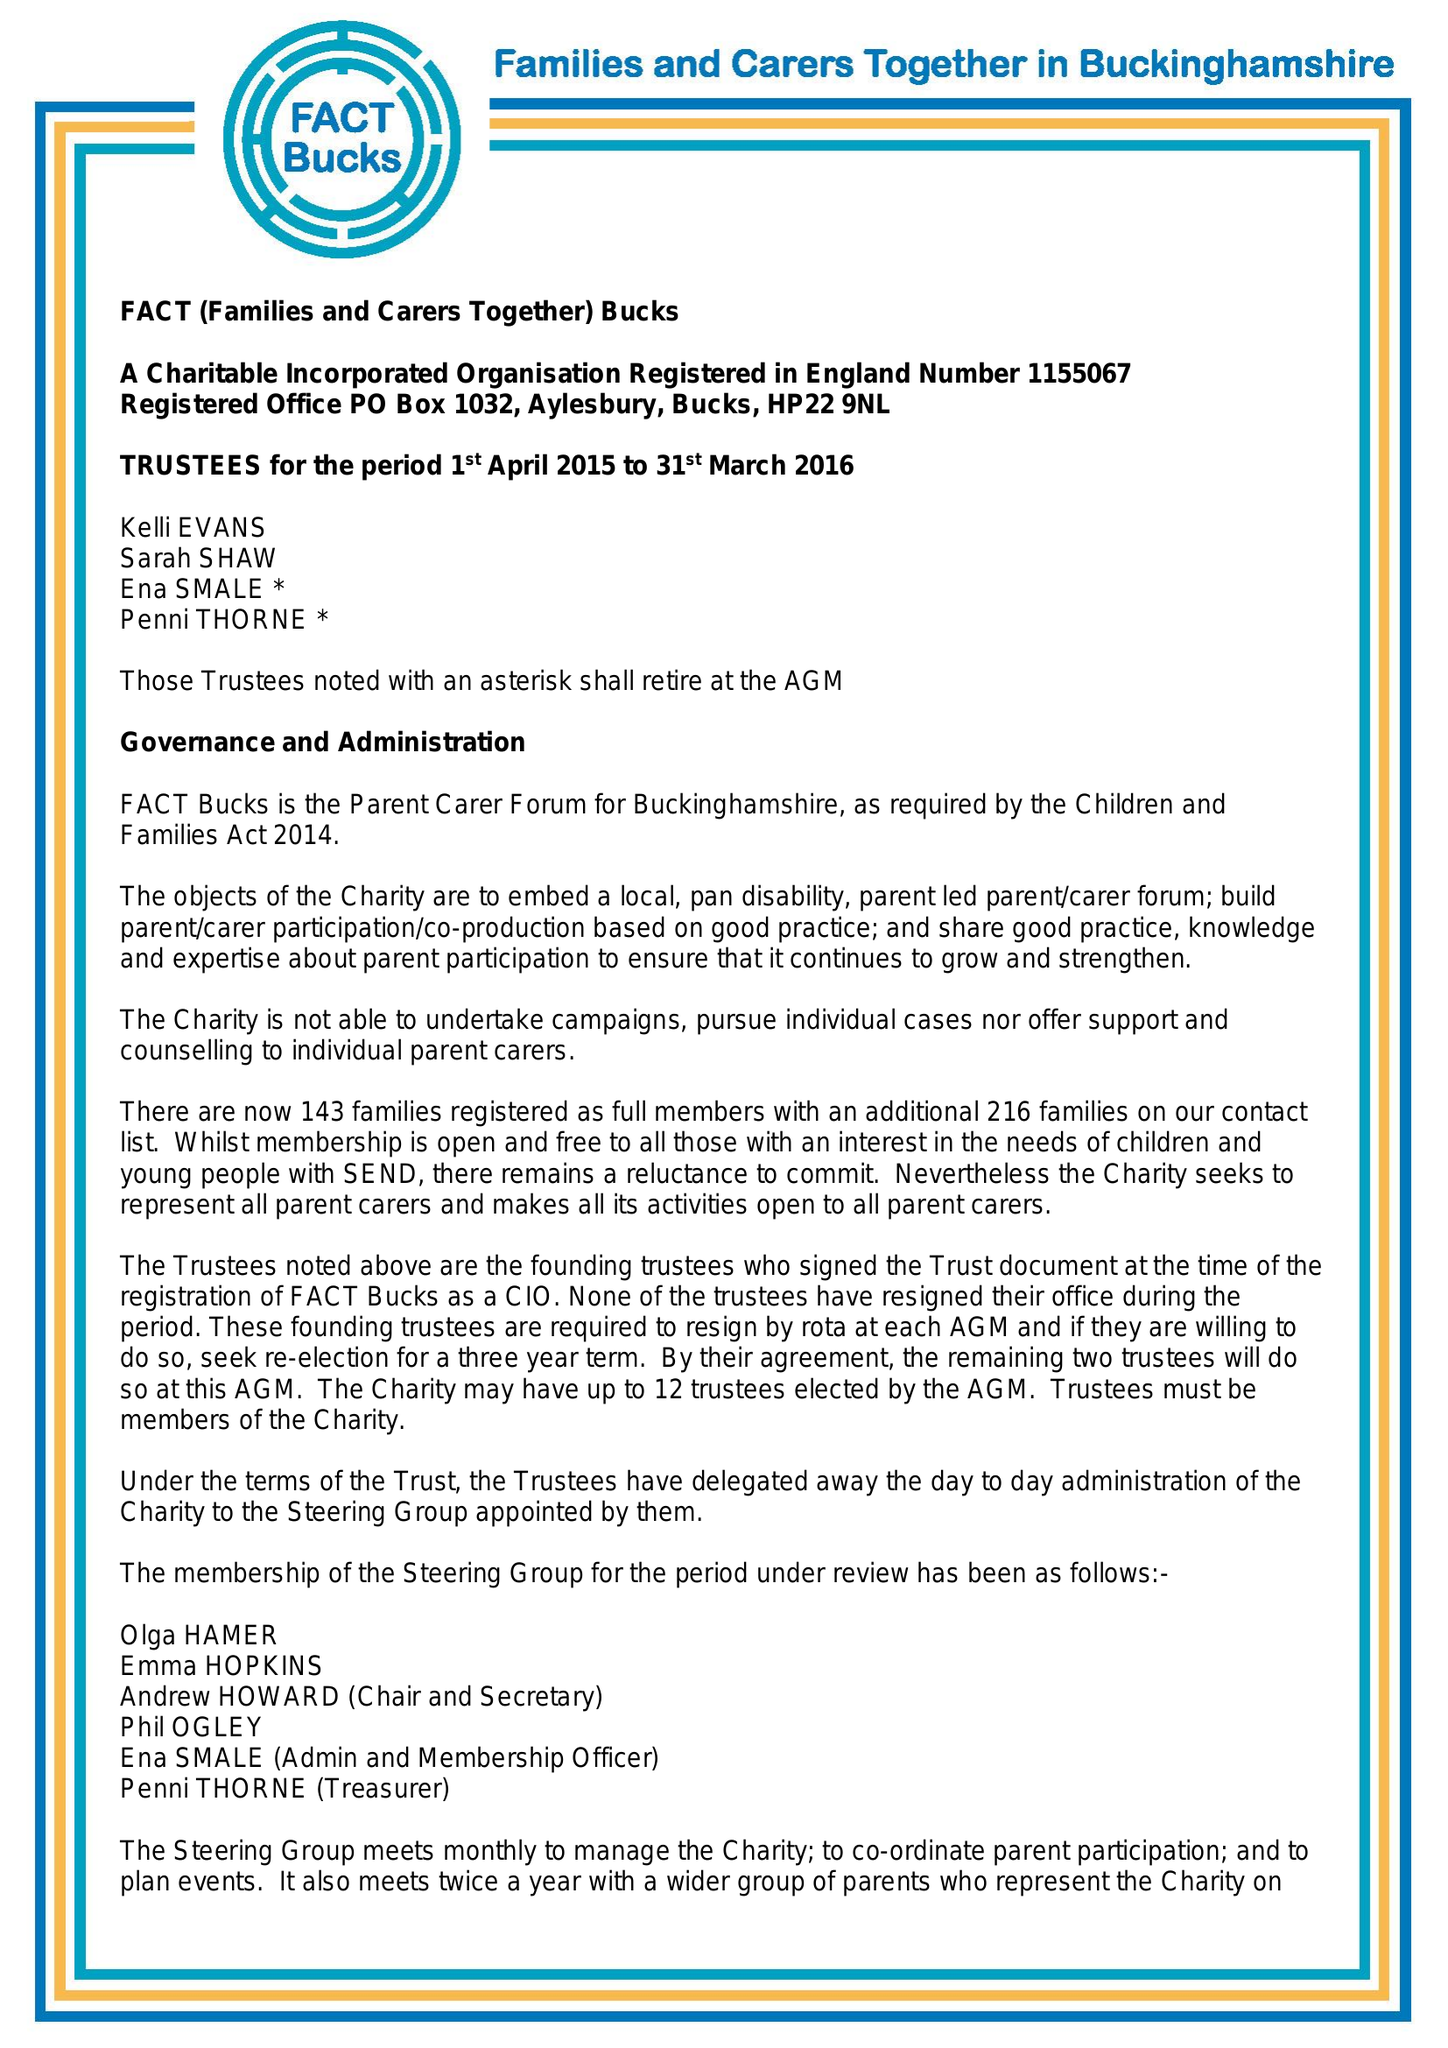What is the value for the charity_name?
Answer the question using a single word or phrase. Fact Bucks 